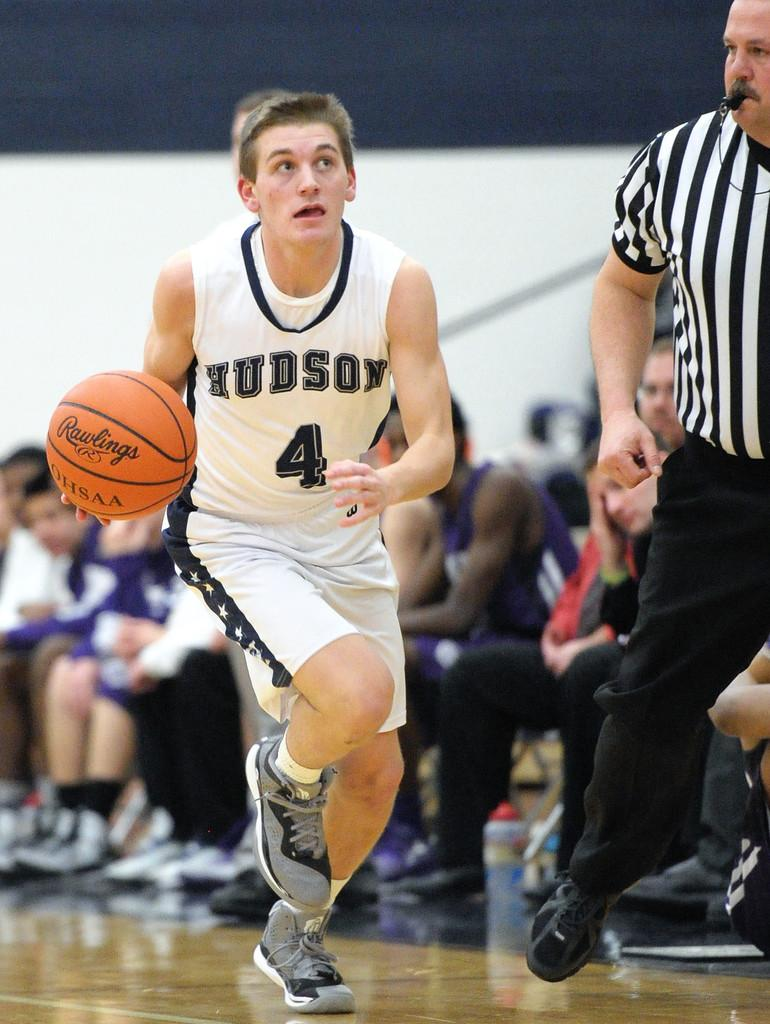<image>
Describe the image concisely. A basketball player, representing Hudson, is in action. 